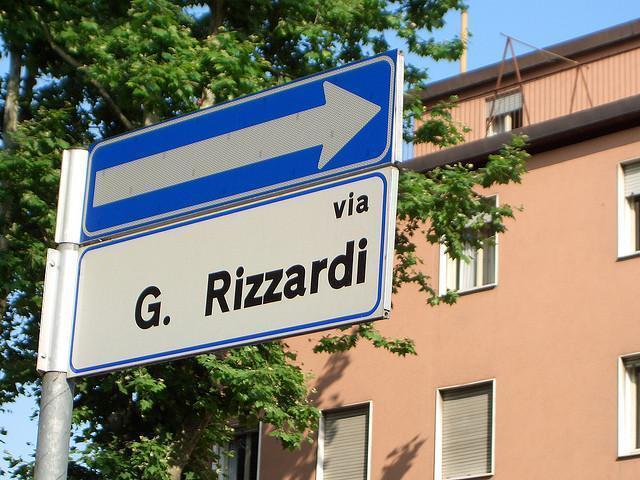How many trees are there?
Give a very brief answer. 1. 